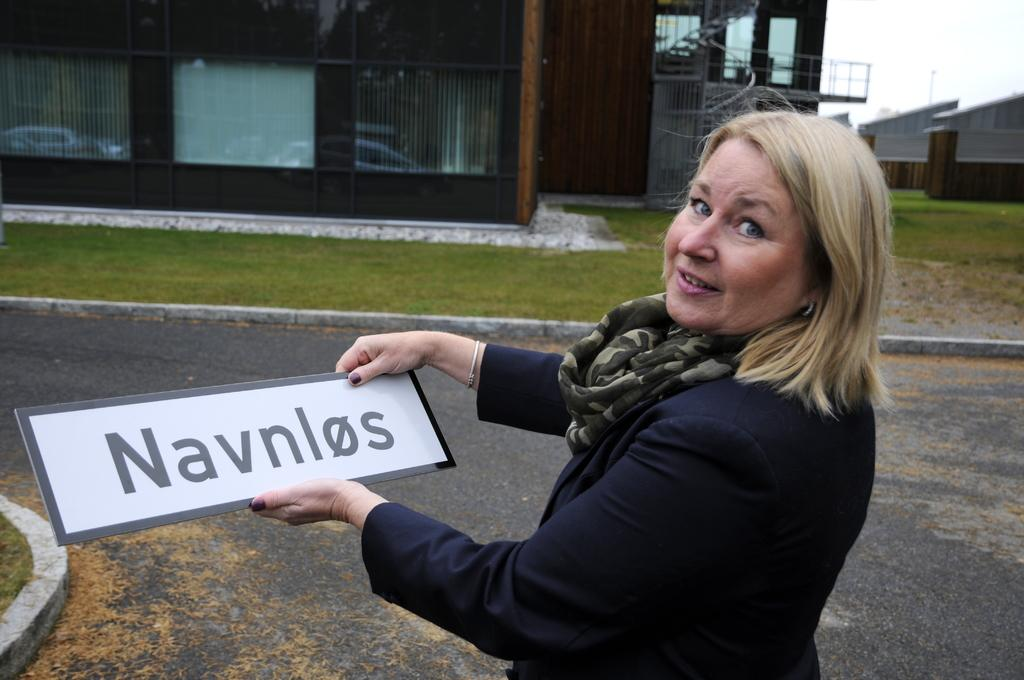What is the hair color of the woman in the image? The woman in the image has blond hair. What is the woman wearing? The woman is wearing a black suit. What is the woman holding in the image? The woman is holding a name board. What can be seen in the background of the image? There is a home in front of a garden in the background of the image. What is visible above the home and garden? The sky is visible above the home and garden. What type of ink is being used by the owl in the image? There is no owl present in the image, and therefore no ink or owl-related activity can be observed. 